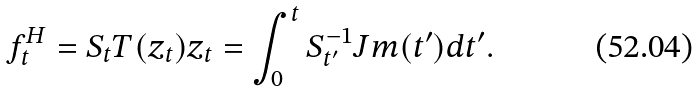Convert formula to latex. <formula><loc_0><loc_0><loc_500><loc_500>f _ { t } ^ { H } = S _ { t } T ( z _ { t } ) z _ { t } = \int _ { 0 } ^ { t } S _ { t ^ { \prime } } ^ { - 1 } J m ( t ^ { \prime } ) d t ^ { \prime } .</formula> 